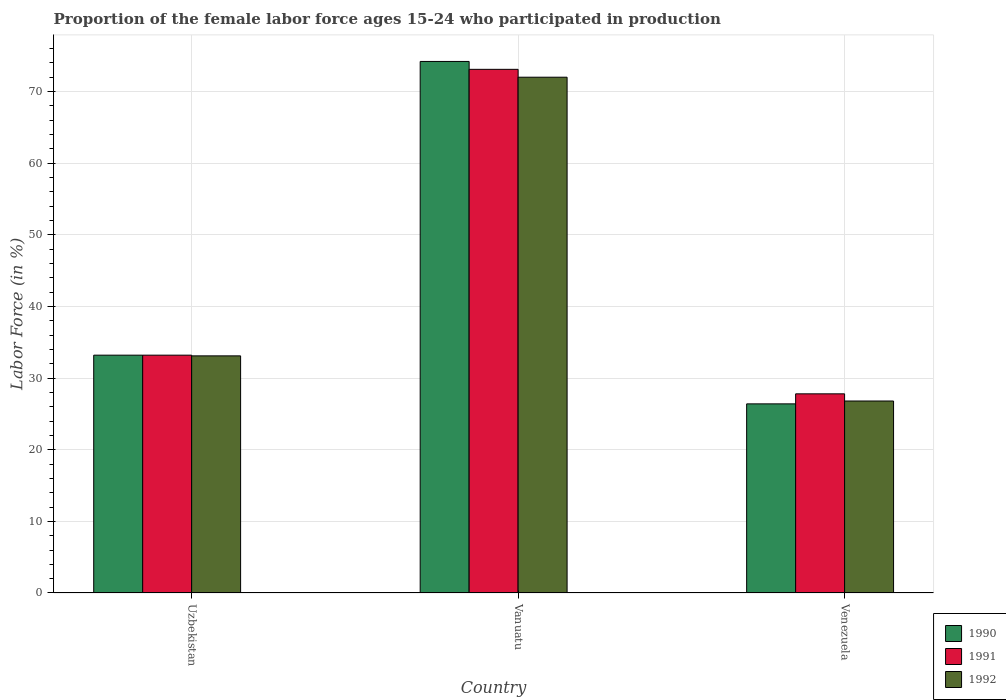How many groups of bars are there?
Make the answer very short. 3. Are the number of bars per tick equal to the number of legend labels?
Provide a short and direct response. Yes. How many bars are there on the 2nd tick from the left?
Offer a terse response. 3. How many bars are there on the 3rd tick from the right?
Your answer should be very brief. 3. What is the label of the 2nd group of bars from the left?
Provide a succinct answer. Vanuatu. In how many cases, is the number of bars for a given country not equal to the number of legend labels?
Offer a terse response. 0. What is the proportion of the female labor force who participated in production in 1990 in Vanuatu?
Give a very brief answer. 74.2. Across all countries, what is the maximum proportion of the female labor force who participated in production in 1992?
Provide a succinct answer. 72. Across all countries, what is the minimum proportion of the female labor force who participated in production in 1990?
Ensure brevity in your answer.  26.4. In which country was the proportion of the female labor force who participated in production in 1990 maximum?
Your response must be concise. Vanuatu. In which country was the proportion of the female labor force who participated in production in 1990 minimum?
Offer a terse response. Venezuela. What is the total proportion of the female labor force who participated in production in 1992 in the graph?
Ensure brevity in your answer.  131.9. What is the difference between the proportion of the female labor force who participated in production in 1990 in Uzbekistan and that in Vanuatu?
Provide a succinct answer. -41. What is the difference between the proportion of the female labor force who participated in production in 1991 in Vanuatu and the proportion of the female labor force who participated in production in 1992 in Uzbekistan?
Provide a succinct answer. 40. What is the average proportion of the female labor force who participated in production in 1990 per country?
Ensure brevity in your answer.  44.6. What is the difference between the proportion of the female labor force who participated in production of/in 1990 and proportion of the female labor force who participated in production of/in 1991 in Vanuatu?
Offer a terse response. 1.1. In how many countries, is the proportion of the female labor force who participated in production in 1992 greater than 2 %?
Ensure brevity in your answer.  3. What is the ratio of the proportion of the female labor force who participated in production in 1991 in Uzbekistan to that in Vanuatu?
Offer a very short reply. 0.45. What is the difference between the highest and the second highest proportion of the female labor force who participated in production in 1992?
Offer a terse response. 38.9. What is the difference between the highest and the lowest proportion of the female labor force who participated in production in 1992?
Offer a terse response. 45.2. Is the sum of the proportion of the female labor force who participated in production in 1992 in Vanuatu and Venezuela greater than the maximum proportion of the female labor force who participated in production in 1990 across all countries?
Keep it short and to the point. Yes. What does the 1st bar from the left in Venezuela represents?
Your response must be concise. 1990. What does the 2nd bar from the right in Venezuela represents?
Your response must be concise. 1991. How many bars are there?
Your answer should be very brief. 9. Are all the bars in the graph horizontal?
Give a very brief answer. No. How many countries are there in the graph?
Your answer should be compact. 3. What is the difference between two consecutive major ticks on the Y-axis?
Give a very brief answer. 10. Where does the legend appear in the graph?
Give a very brief answer. Bottom right. What is the title of the graph?
Provide a short and direct response. Proportion of the female labor force ages 15-24 who participated in production. What is the Labor Force (in %) of 1990 in Uzbekistan?
Provide a short and direct response. 33.2. What is the Labor Force (in %) of 1991 in Uzbekistan?
Make the answer very short. 33.2. What is the Labor Force (in %) of 1992 in Uzbekistan?
Make the answer very short. 33.1. What is the Labor Force (in %) of 1990 in Vanuatu?
Offer a very short reply. 74.2. What is the Labor Force (in %) of 1991 in Vanuatu?
Make the answer very short. 73.1. What is the Labor Force (in %) in 1990 in Venezuela?
Offer a terse response. 26.4. What is the Labor Force (in %) in 1991 in Venezuela?
Keep it short and to the point. 27.8. What is the Labor Force (in %) of 1992 in Venezuela?
Provide a short and direct response. 26.8. Across all countries, what is the maximum Labor Force (in %) in 1990?
Provide a short and direct response. 74.2. Across all countries, what is the maximum Labor Force (in %) in 1991?
Offer a very short reply. 73.1. Across all countries, what is the maximum Labor Force (in %) of 1992?
Ensure brevity in your answer.  72. Across all countries, what is the minimum Labor Force (in %) in 1990?
Your response must be concise. 26.4. Across all countries, what is the minimum Labor Force (in %) of 1991?
Your response must be concise. 27.8. Across all countries, what is the minimum Labor Force (in %) in 1992?
Your response must be concise. 26.8. What is the total Labor Force (in %) in 1990 in the graph?
Your answer should be very brief. 133.8. What is the total Labor Force (in %) in 1991 in the graph?
Provide a succinct answer. 134.1. What is the total Labor Force (in %) of 1992 in the graph?
Provide a succinct answer. 131.9. What is the difference between the Labor Force (in %) of 1990 in Uzbekistan and that in Vanuatu?
Provide a succinct answer. -41. What is the difference between the Labor Force (in %) of 1991 in Uzbekistan and that in Vanuatu?
Provide a short and direct response. -39.9. What is the difference between the Labor Force (in %) of 1992 in Uzbekistan and that in Vanuatu?
Your answer should be compact. -38.9. What is the difference between the Labor Force (in %) in 1990 in Vanuatu and that in Venezuela?
Your answer should be very brief. 47.8. What is the difference between the Labor Force (in %) in 1991 in Vanuatu and that in Venezuela?
Ensure brevity in your answer.  45.3. What is the difference between the Labor Force (in %) in 1992 in Vanuatu and that in Venezuela?
Your answer should be compact. 45.2. What is the difference between the Labor Force (in %) of 1990 in Uzbekistan and the Labor Force (in %) of 1991 in Vanuatu?
Ensure brevity in your answer.  -39.9. What is the difference between the Labor Force (in %) in 1990 in Uzbekistan and the Labor Force (in %) in 1992 in Vanuatu?
Provide a succinct answer. -38.8. What is the difference between the Labor Force (in %) of 1991 in Uzbekistan and the Labor Force (in %) of 1992 in Vanuatu?
Your answer should be compact. -38.8. What is the difference between the Labor Force (in %) in 1990 in Uzbekistan and the Labor Force (in %) in 1991 in Venezuela?
Your answer should be very brief. 5.4. What is the difference between the Labor Force (in %) of 1991 in Uzbekistan and the Labor Force (in %) of 1992 in Venezuela?
Provide a short and direct response. 6.4. What is the difference between the Labor Force (in %) of 1990 in Vanuatu and the Labor Force (in %) of 1991 in Venezuela?
Provide a succinct answer. 46.4. What is the difference between the Labor Force (in %) of 1990 in Vanuatu and the Labor Force (in %) of 1992 in Venezuela?
Offer a very short reply. 47.4. What is the difference between the Labor Force (in %) of 1991 in Vanuatu and the Labor Force (in %) of 1992 in Venezuela?
Your answer should be very brief. 46.3. What is the average Labor Force (in %) in 1990 per country?
Make the answer very short. 44.6. What is the average Labor Force (in %) in 1991 per country?
Your answer should be very brief. 44.7. What is the average Labor Force (in %) in 1992 per country?
Offer a terse response. 43.97. What is the difference between the Labor Force (in %) in 1990 and Labor Force (in %) in 1991 in Uzbekistan?
Make the answer very short. 0. What is the difference between the Labor Force (in %) of 1991 and Labor Force (in %) of 1992 in Uzbekistan?
Your response must be concise. 0.1. What is the difference between the Labor Force (in %) in 1990 and Labor Force (in %) in 1992 in Vanuatu?
Give a very brief answer. 2.2. What is the difference between the Labor Force (in %) in 1990 and Labor Force (in %) in 1992 in Venezuela?
Offer a very short reply. -0.4. What is the ratio of the Labor Force (in %) in 1990 in Uzbekistan to that in Vanuatu?
Your answer should be compact. 0.45. What is the ratio of the Labor Force (in %) of 1991 in Uzbekistan to that in Vanuatu?
Provide a succinct answer. 0.45. What is the ratio of the Labor Force (in %) of 1992 in Uzbekistan to that in Vanuatu?
Ensure brevity in your answer.  0.46. What is the ratio of the Labor Force (in %) of 1990 in Uzbekistan to that in Venezuela?
Make the answer very short. 1.26. What is the ratio of the Labor Force (in %) of 1991 in Uzbekistan to that in Venezuela?
Keep it short and to the point. 1.19. What is the ratio of the Labor Force (in %) in 1992 in Uzbekistan to that in Venezuela?
Your answer should be very brief. 1.24. What is the ratio of the Labor Force (in %) of 1990 in Vanuatu to that in Venezuela?
Your answer should be compact. 2.81. What is the ratio of the Labor Force (in %) in 1991 in Vanuatu to that in Venezuela?
Ensure brevity in your answer.  2.63. What is the ratio of the Labor Force (in %) of 1992 in Vanuatu to that in Venezuela?
Provide a succinct answer. 2.69. What is the difference between the highest and the second highest Labor Force (in %) in 1990?
Keep it short and to the point. 41. What is the difference between the highest and the second highest Labor Force (in %) of 1991?
Give a very brief answer. 39.9. What is the difference between the highest and the second highest Labor Force (in %) of 1992?
Make the answer very short. 38.9. What is the difference between the highest and the lowest Labor Force (in %) in 1990?
Your response must be concise. 47.8. What is the difference between the highest and the lowest Labor Force (in %) of 1991?
Give a very brief answer. 45.3. What is the difference between the highest and the lowest Labor Force (in %) in 1992?
Provide a succinct answer. 45.2. 